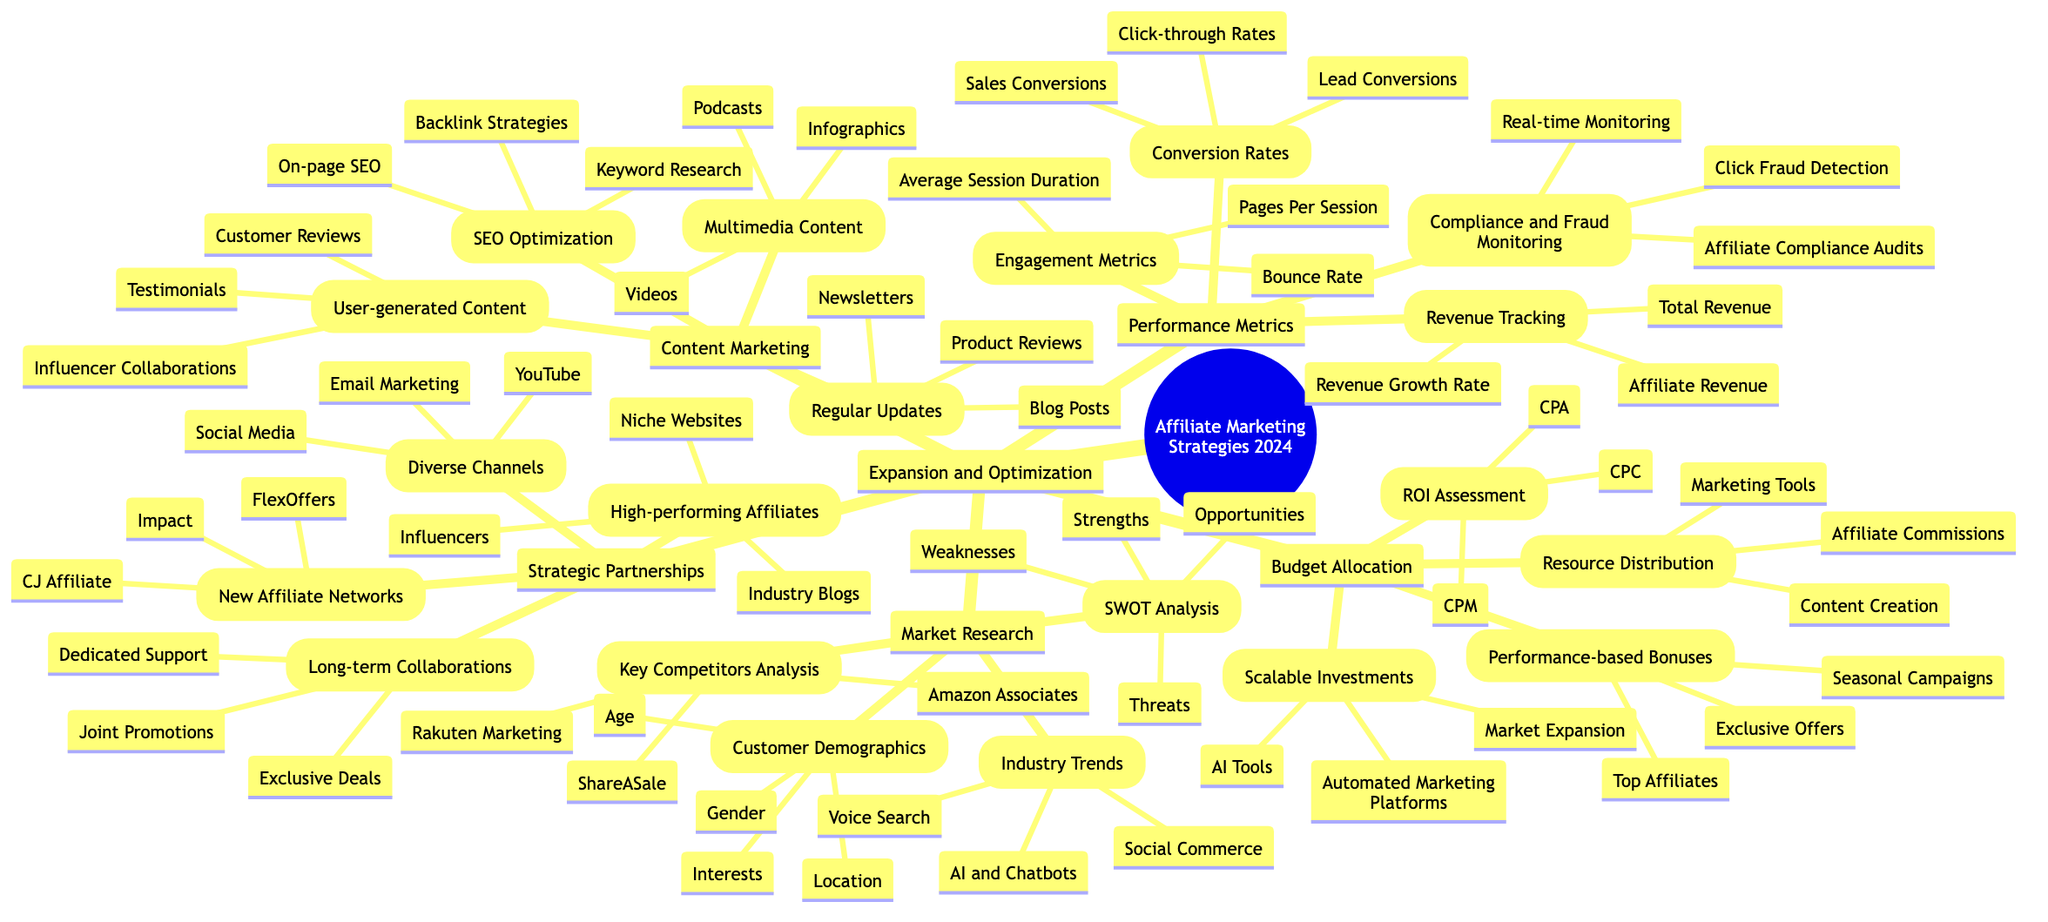What are the high-performing affiliates listed? The diagram shows that high-performing affiliates include Influencers, Industry Blogs, and Niche Websites, located under the "Strategic Partnerships" branch, specifically in the "High-performing Affiliates" section.
Answer: Influencers, Industry Blogs, Niche Websites What does the SWOT analysis address in Market Research? The SWOT analysis in the Market Research section covers strengths, weaknesses, opportunities, and threats, identified as key areas to assess competitive positioning.
Answer: Strengths, Weaknesses, Opportunities, Threats How many new affiliate networks are mentioned? The diagram indicates there are three new affiliate networks: CJ Affiliate, Impact, and FlexOffers, found under the "New Affiliate Networks" in the "Strategic Partnerships" section.
Answer: 3 What types of content are included in Multimedia Content? According to the Content Marketing section, Multimedia Content consists of Videos, Infographics, and Podcasts. This information is under the "Multimedia Content" branch of the Content Marketing category.
Answer: Videos, Infographics, Podcasts Which performance metric involves compliance monitoring? The Performance Metrics section mentions Compliance and Fraud Monitoring, which includes Click Fraud Detection, Affiliate Compliance Audits, and Real-time Monitoring, highlighting the importance of compliance.
Answer: Compliance and Fraud Monitoring What are the three components of the ROI assessment? The diagram states that the ROI Assessment includes CPA, CPC, and CPM, which are financial metrics used to gauge the effectiveness of affiliate marketing spend, located under the "Budget Allocation" branch.
Answer: CPA, CPC, CPM How does Strategic Partnerships relate to Diverse Channels? The "Diverse Channels" from the "Strategic Partnerships" section emphasizes that partnerships can function across various platforms like Email Marketing, Social Media, and YouTube, indicating an interconnected approach to reach a broader audience.
Answer: Diverse Channels: Email Marketing, Social Media, YouTube What is one type of User-generated Content mentioned? The diagram lists Customer Reviews as one type of User-generated Content, which is an essential component of the Content Marketing strategy in fostering trust and engagement with potential customers.
Answer: Customer Reviews How is budget allocated for performance-based bonuses? The "Performance-based Bonuses" as a part of the Budget Allocation section includes distribution to Top Affiliates, seasonal campaigns, and exclusive offers, reflecting a strategy focused on incentivizing high-performing affiliates.
Answer: Top Affiliates, Seasonal Campaigns, Exclusive Offers 